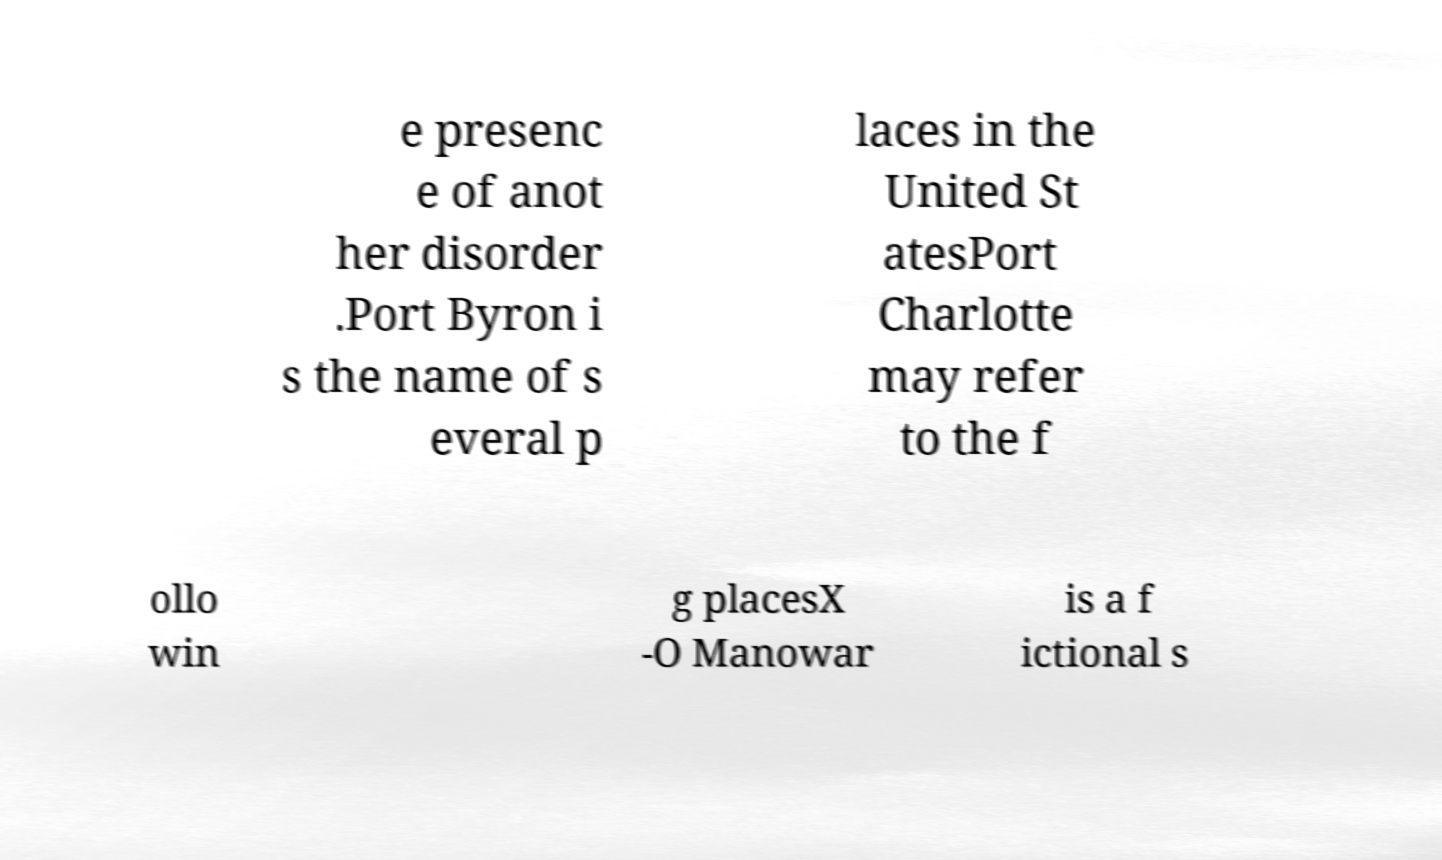Please read and relay the text visible in this image. What does it say? e presenc e of anot her disorder .Port Byron i s the name of s everal p laces in the United St atesPort Charlotte may refer to the f ollo win g placesX -O Manowar is a f ictional s 